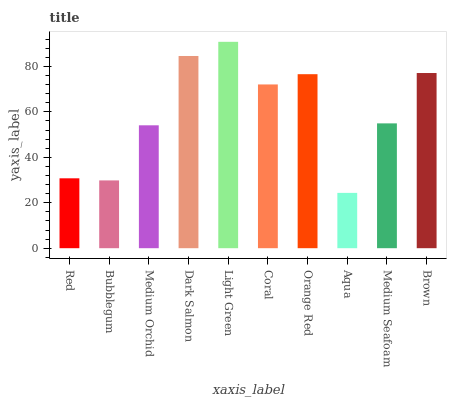Is Aqua the minimum?
Answer yes or no. Yes. Is Light Green the maximum?
Answer yes or no. Yes. Is Bubblegum the minimum?
Answer yes or no. No. Is Bubblegum the maximum?
Answer yes or no. No. Is Red greater than Bubblegum?
Answer yes or no. Yes. Is Bubblegum less than Red?
Answer yes or no. Yes. Is Bubblegum greater than Red?
Answer yes or no. No. Is Red less than Bubblegum?
Answer yes or no. No. Is Coral the high median?
Answer yes or no. Yes. Is Medium Seafoam the low median?
Answer yes or no. Yes. Is Brown the high median?
Answer yes or no. No. Is Red the low median?
Answer yes or no. No. 